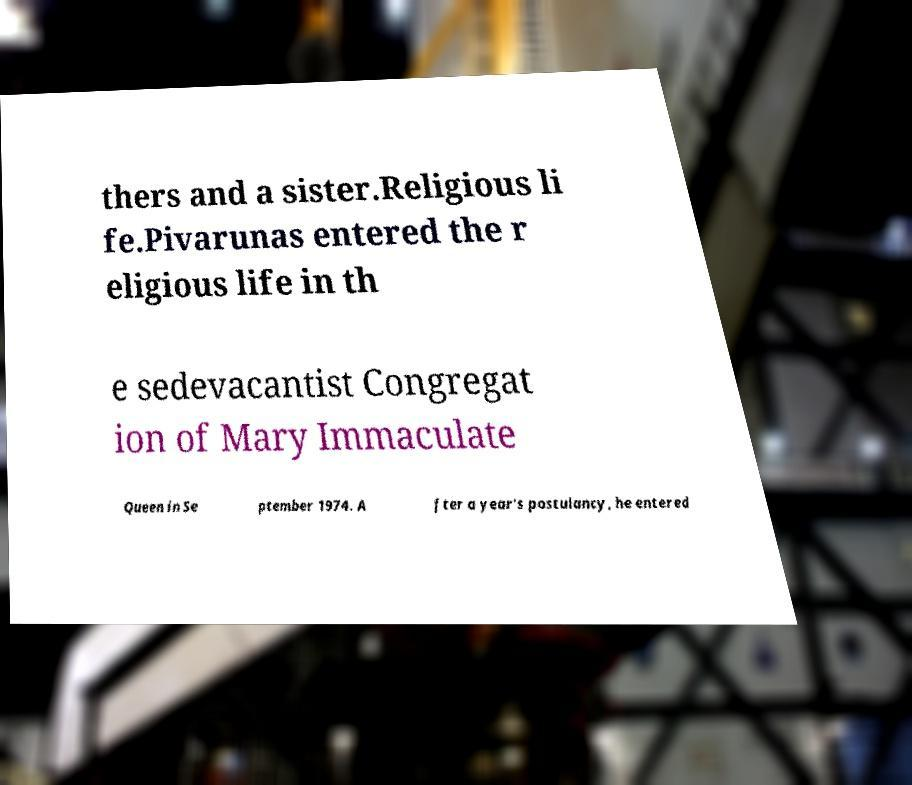Can you accurately transcribe the text from the provided image for me? thers and a sister.Religious li fe.Pivarunas entered the r eligious life in th e sedevacantist Congregat ion of Mary Immaculate Queen in Se ptember 1974. A fter a year's postulancy, he entered 